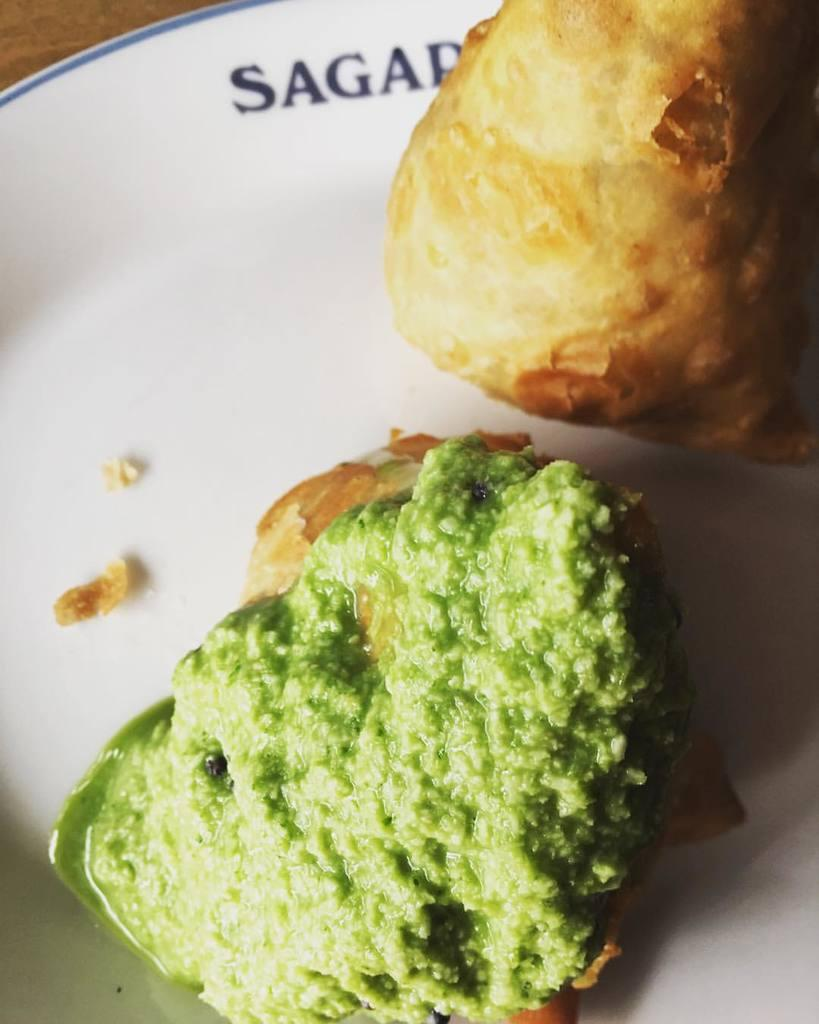What type of food is present in the image? There are snacks in a plate in the image. Can you describe the snacks in more detail? Unfortunately, the image does not provide enough detail to describe the snacks further. Is there any utensil or accompaniment visible with the snacks? The image does not show any utensils or accompaniments with the snacks. What is the writing on the snacks in the image? There is no writing visible on the snacks in the image. What type of pickle is being used to cause the snacks to become soggy in the image? There are no pickles present in the image, and the snacks do not appear to be soggy. 